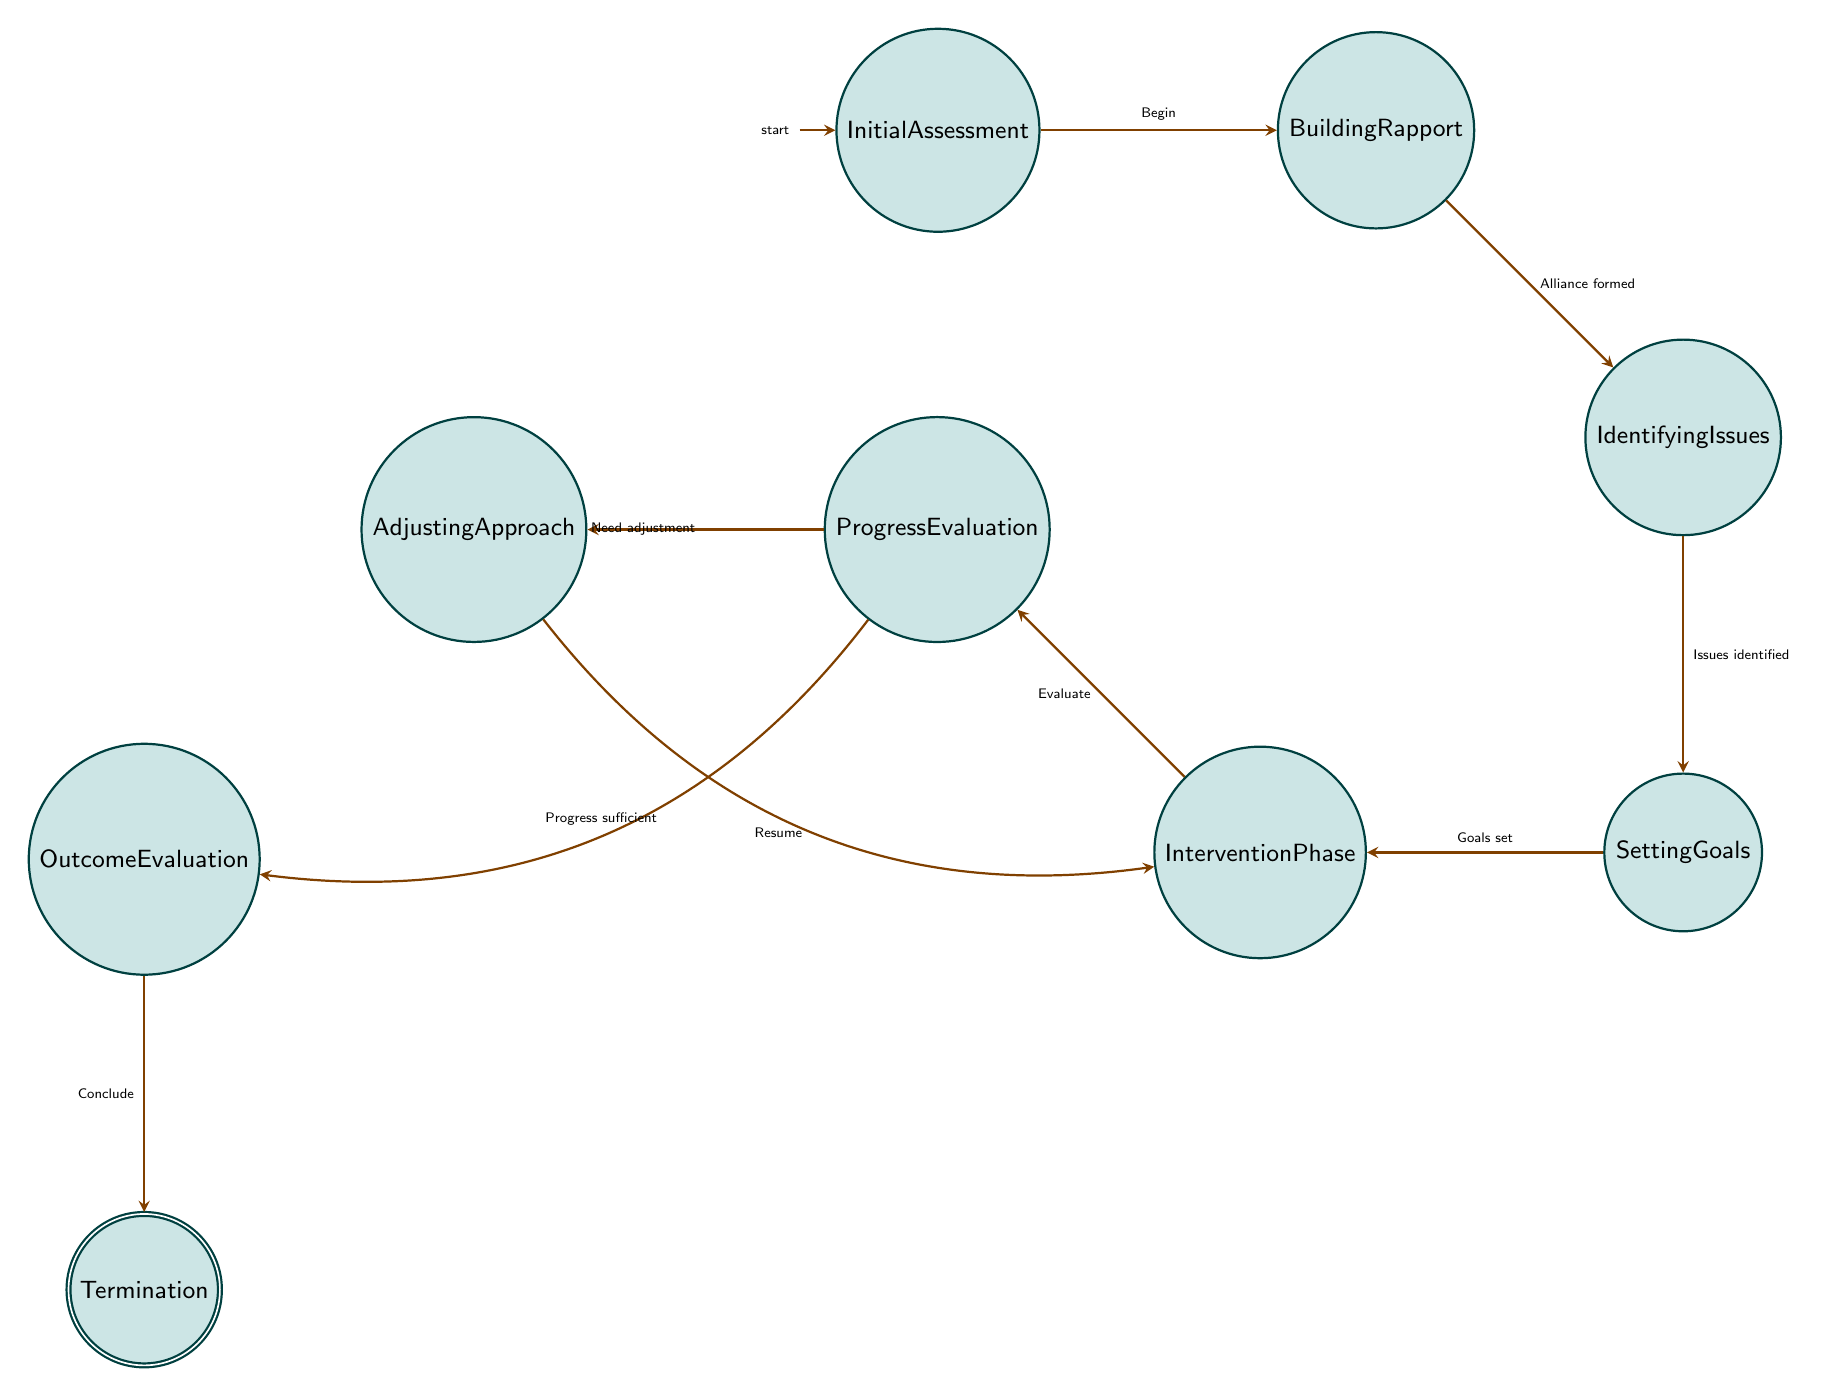What is the first state in the diagram? The initial state, or starting point of the diagram, is designated as "Initial Assessment". This is the first node listed.
Answer: Initial Assessment How many states are there in total? By counting the nodes in the diagram, there are a total of nine states represented.
Answer: Nine What indicates a successful transition between "Identifying Issues" and "Setting Goals"? The transition from "Identifying Issues" to "Setting Goals" occurs once specific issues are identified, which is indicated by the labeled edge.
Answer: Issues identified What happens after the "Progress Evaluation"? Following the "Progress Evaluation", there are two possible transitions: one leads to "Adjusting Approach" if adjustments are necessary, and the other leads to "Outcome Evaluation" if sufficient progress is made. This bifurcation is shown by two differently directed edges coming out of "Progress Evaluation".
Answer: Adjusting Approach or Outcome Evaluation Which state follows "Intervention Phase"? The "Intervention Phase" leads to "Progress Evaluation", as the next step is to evaluate the interventions that have been applied. This is shown by the directed edge linking the two states.
Answer: Progress Evaluation How many transitions are there from "Adjusting Approach"? There is one transition from "Adjusting Approach" back to "Intervention Phase", allowing the therapist to resume modified interventions based on the client's progress.
Answer: One What is the last state in the process? The last state in the process, which signifies the conclusion of therapy, is "Termination". This is the final node in the sequence of states.
Answer: Termination Which states have a direct relationship? Each state listed has direct relationships indicating transitions based on specific conditions; for example, "Building Rapport" connects to "Identifying Issues", demonstrating how rapport can enable deeper issue exploration.
Answer: Multiple direct relationships What is the purpose of the "Outcome Evaluation" state? The "Outcome Evaluation" state is intended for assessing the final results of the therapy sessions, determining the effectiveness and overall outcomes achieved through the therapy process.
Answer: Assessing final results 